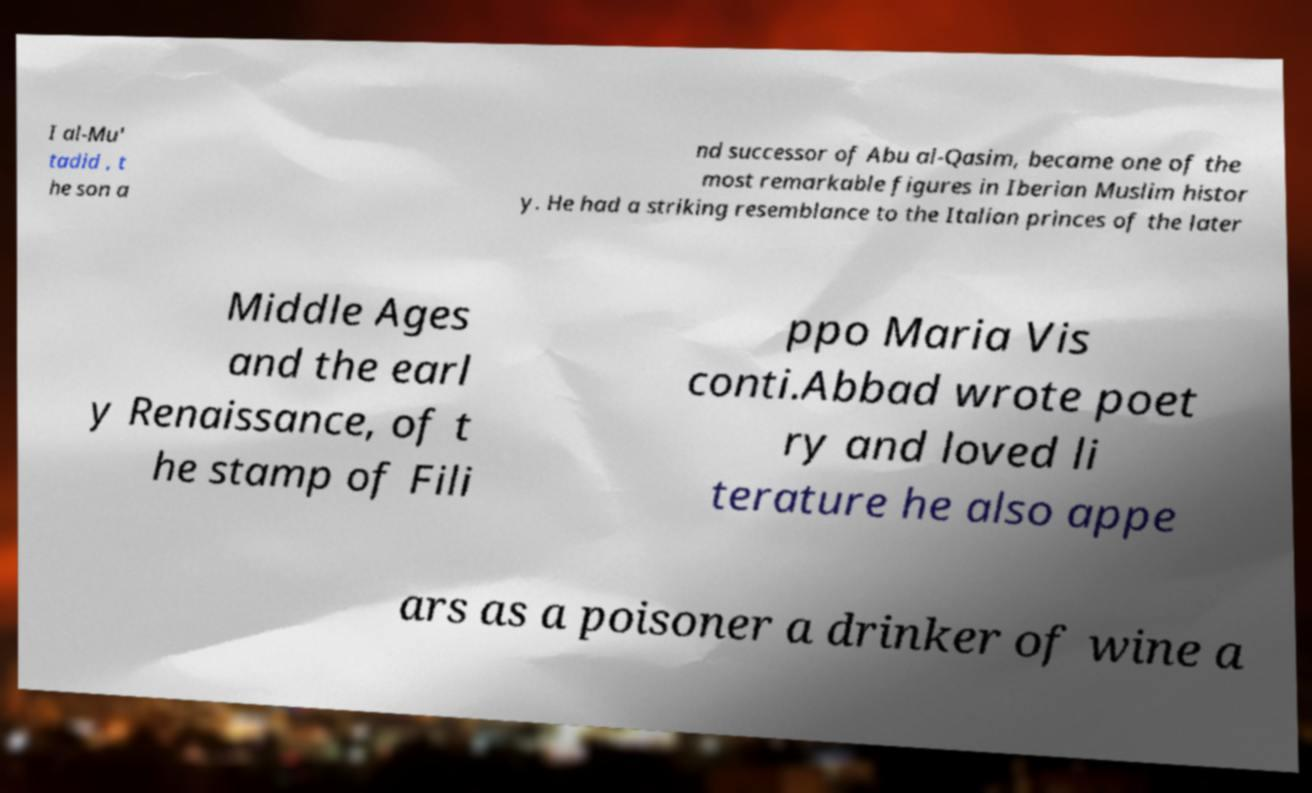What messages or text are displayed in this image? I need them in a readable, typed format. I al-Mu' tadid , t he son a nd successor of Abu al-Qasim, became one of the most remarkable figures in Iberian Muslim histor y. He had a striking resemblance to the Italian princes of the later Middle Ages and the earl y Renaissance, of t he stamp of Fili ppo Maria Vis conti.Abbad wrote poet ry and loved li terature he also appe ars as a poisoner a drinker of wine a 